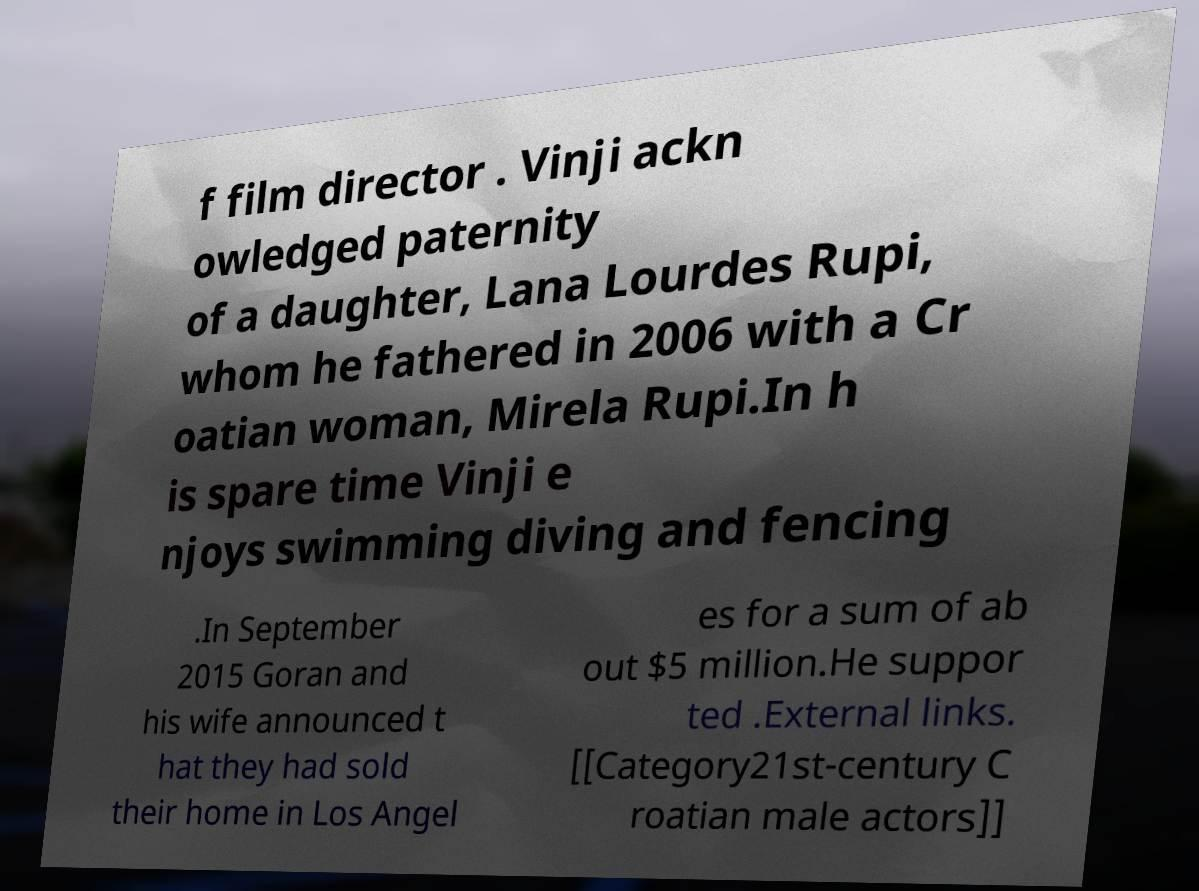Please read and relay the text visible in this image. What does it say? f film director . Vinji ackn owledged paternity of a daughter, Lana Lourdes Rupi, whom he fathered in 2006 with a Cr oatian woman, Mirela Rupi.In h is spare time Vinji e njoys swimming diving and fencing .In September 2015 Goran and his wife announced t hat they had sold their home in Los Angel es for a sum of ab out $5 million.He suppor ted .External links. [[Category21st-century C roatian male actors]] 